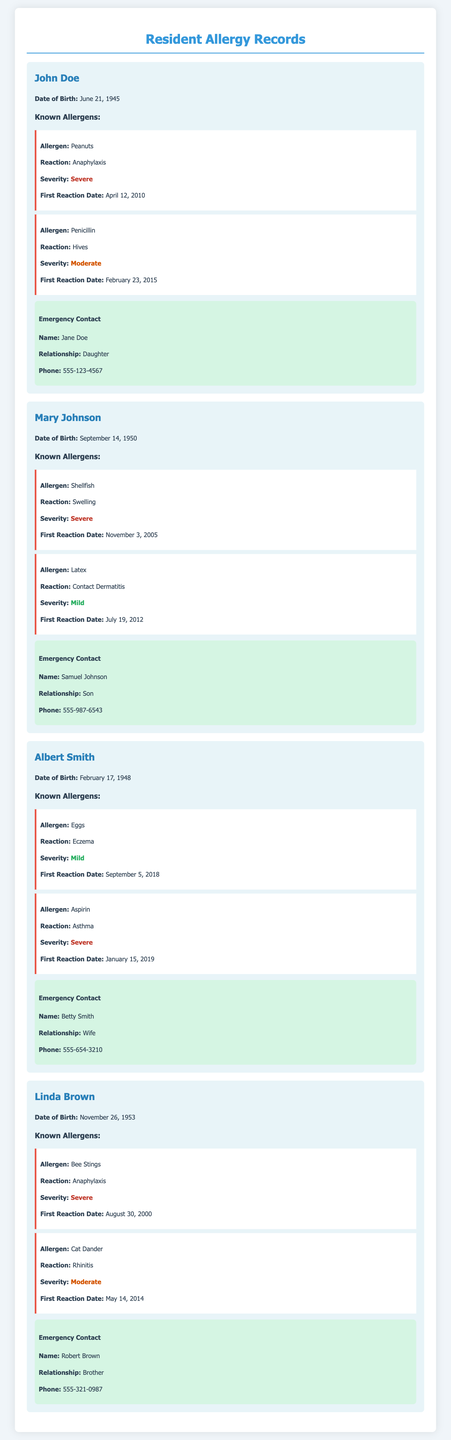What is the name of the resident with the first reaction to peanuts? The resident with the first reaction to peanuts is John Doe.
Answer: John Doe What is Mary Johnson's date of birth? Mary Johnson's date of birth is September 14, 1950.
Answer: September 14, 1950 How many allergens does Albert Smith have listed? Albert Smith has two allergens listed in the document.
Answer: Two What is the reaction severity of Linda Brown's allergy to Bee Stings? The reaction severity of Linda Brown's allergy to Bee Stings is classified as severe.
Answer: Severe Who is Mary Johnson's emergency contact? Mary Johnson's emergency contact is Samuel Johnson.
Answer: Samuel Johnson When did John Doe first react to Penicillin? John Doe first reacted to Penicillin on February 23, 2015.
Answer: February 23, 2015 Which resident has an allergy to Shellfish? The resident with an allergy to Shellfish is Mary Johnson.
Answer: Mary Johnson What type of reaction does Albert Smith experience from Aspirin? Albert Smith experiences asthma as a reaction to Aspirin.
Answer: Asthma 